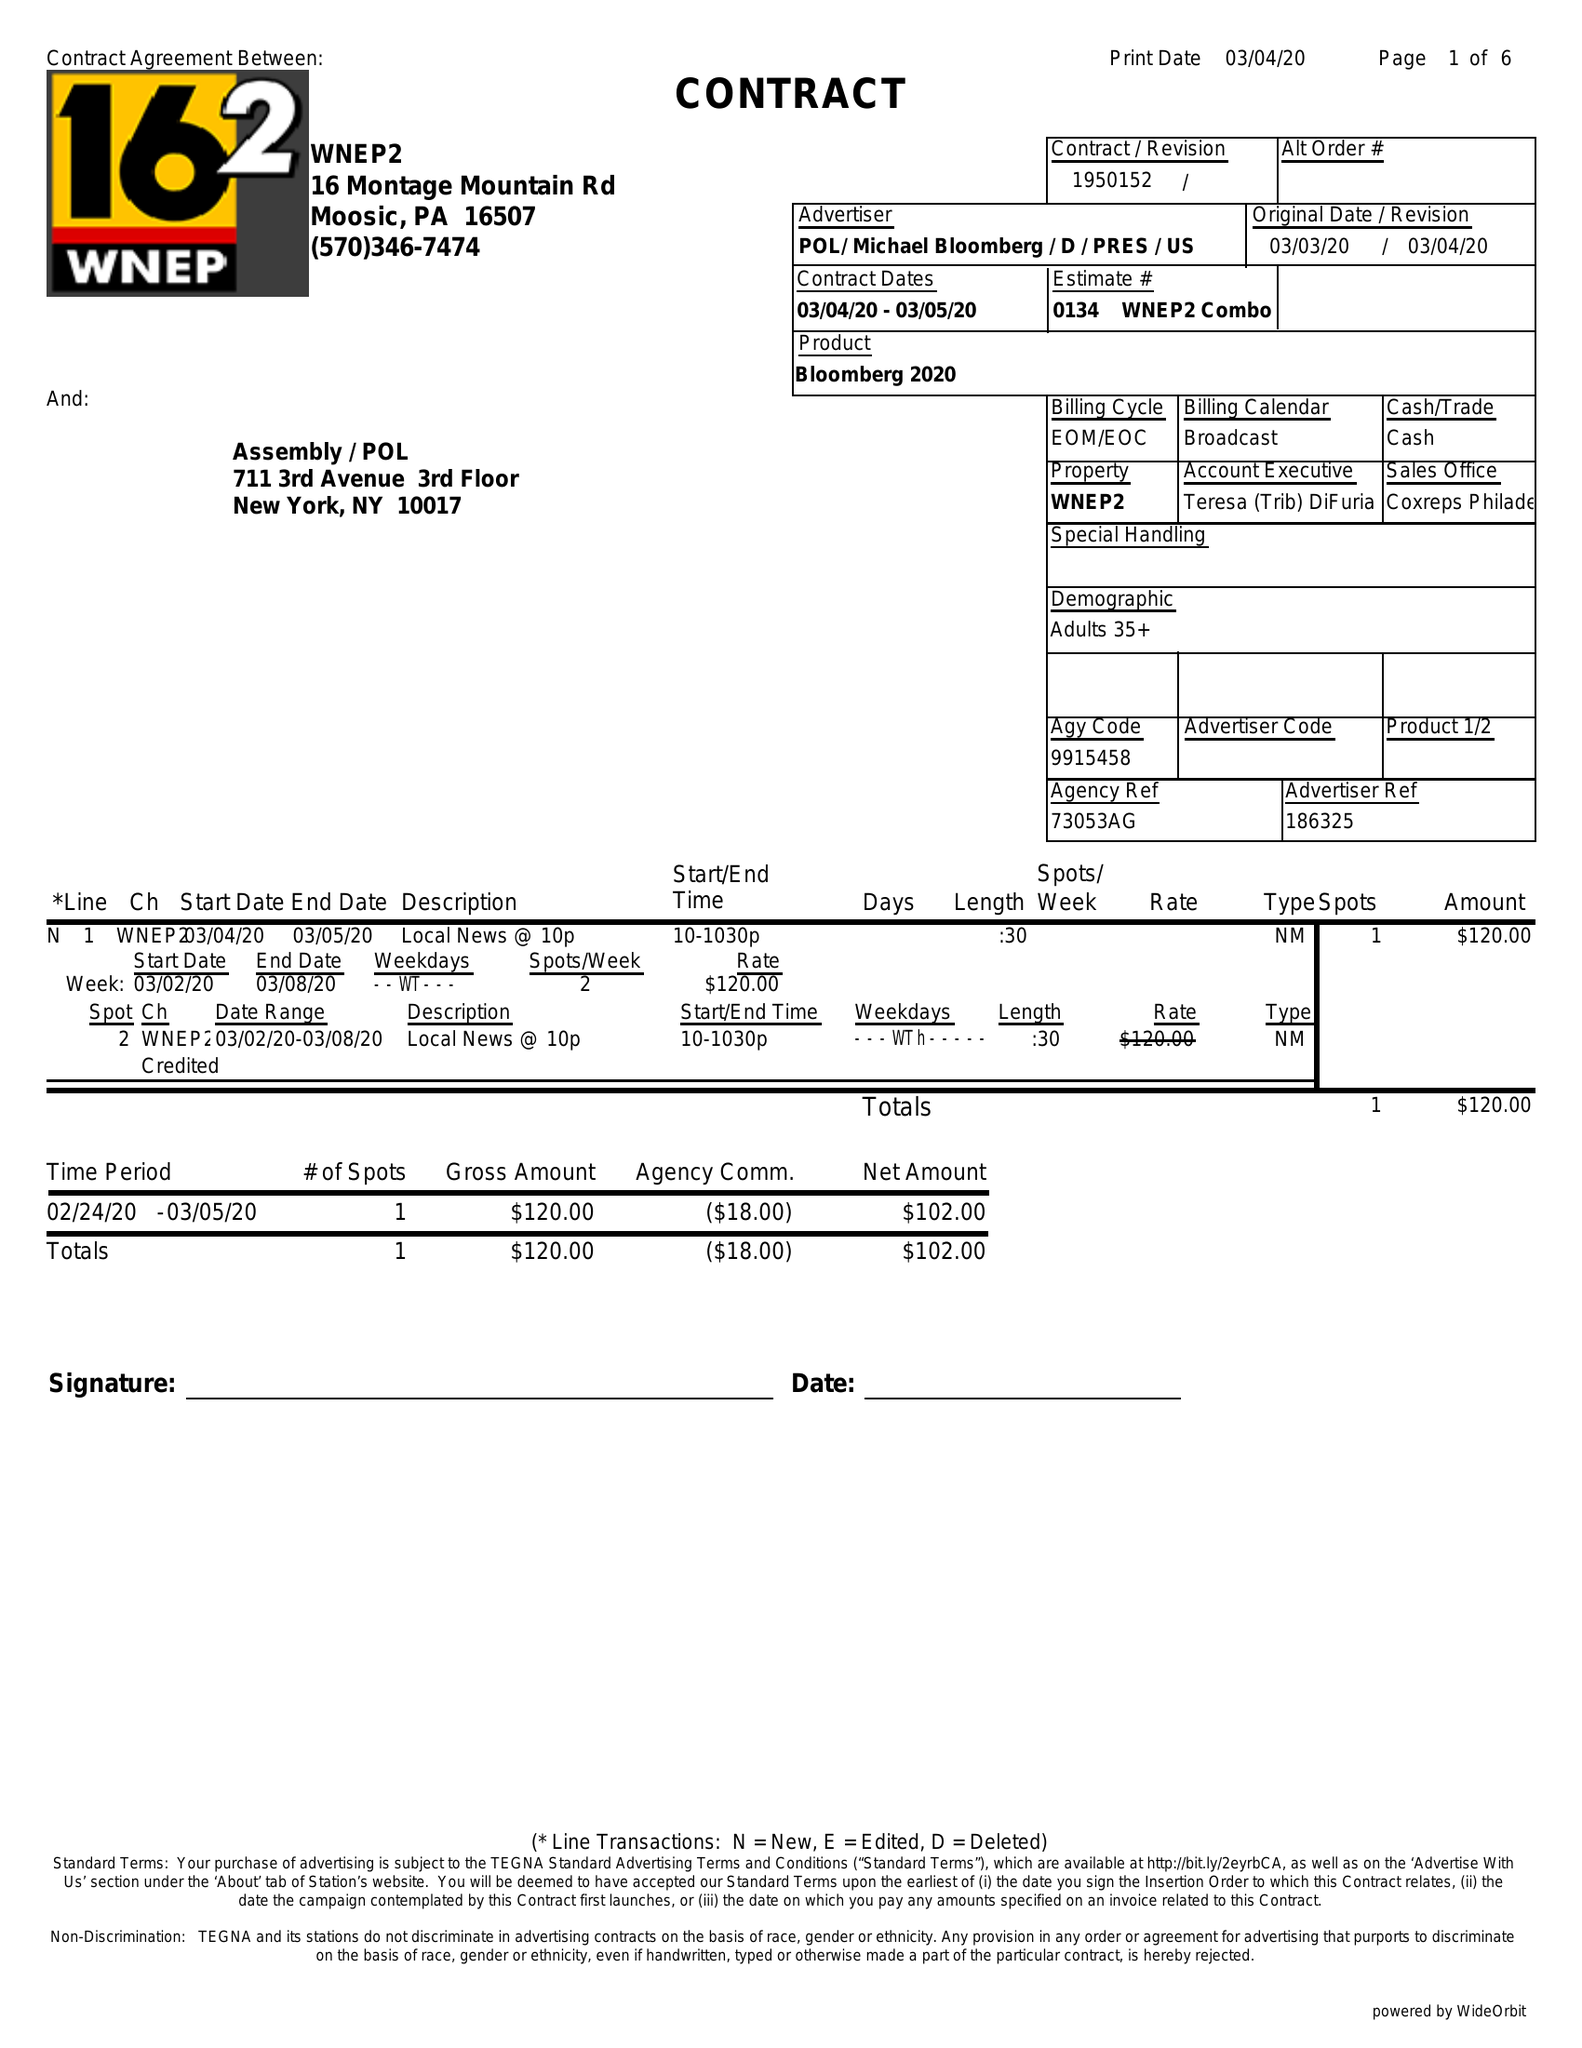What is the value for the contract_num?
Answer the question using a single word or phrase. 1950152 